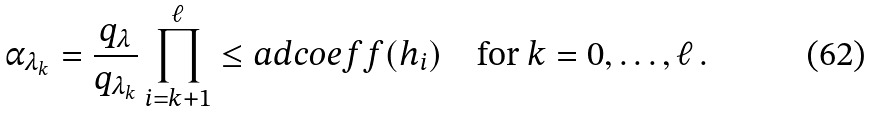Convert formula to latex. <formula><loc_0><loc_0><loc_500><loc_500>\alpha _ { \lambda _ { k } } = \frac { q _ { \lambda } } { q _ { \lambda _ { k } } } \prod _ { i = k + 1 } ^ { \ell } \leq a d c o e f f ( h _ { i } ) \quad \text {for } k = 0 , \dots , \ell \, .</formula> 